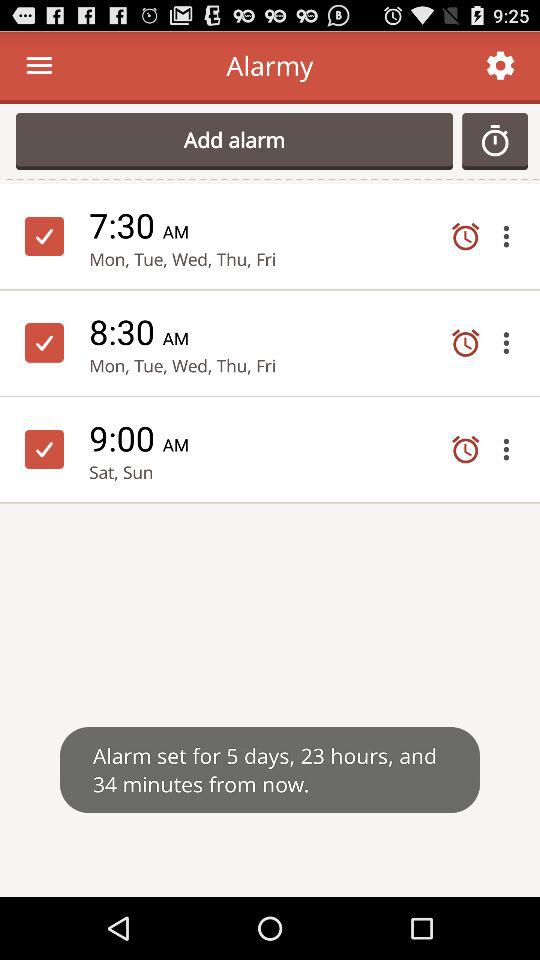What is the given date? The given date is December 2016. 